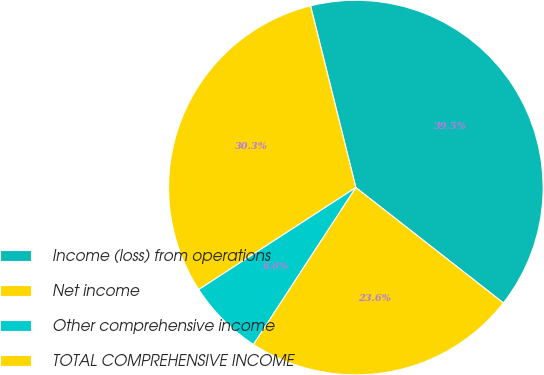Convert chart to OTSL. <chart><loc_0><loc_0><loc_500><loc_500><pie_chart><fcel>Income (loss) from operations<fcel>Net income<fcel>Other comprehensive income<fcel>TOTAL COMPREHENSIVE INCOME<nl><fcel>39.45%<fcel>30.27%<fcel>6.64%<fcel>23.63%<nl></chart> 